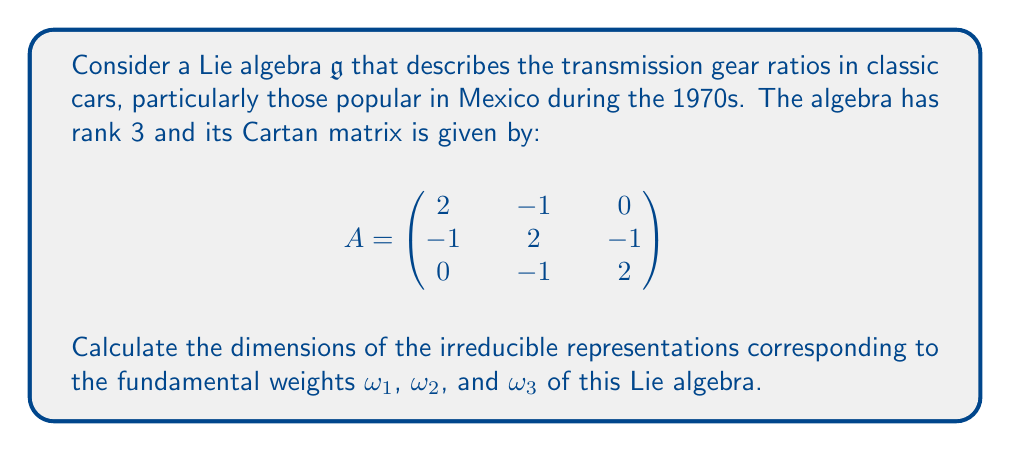Help me with this question. To find the dimensions of the irreducible representations, we'll use the Weyl dimension formula. For a representation with highest weight $\lambda$, the dimension is given by:

$$\dim V(\lambda) = \prod_{\alpha \in \Phi^+} \frac{(\lambda + \rho, \alpha)}{(\rho, \alpha)}$$

where $\Phi^+$ is the set of positive roots, and $\rho$ is half the sum of the positive roots.

1) First, we need to identify the Lie algebra. The Cartan matrix corresponds to the $A_3$ Lie algebra, which is isomorphic to $\mathfrak{sl}(4, \mathbb{C})$.

2) The positive roots for $A_3$ are:
   $\alpha_1, \alpha_2, \alpha_3, \alpha_1 + \alpha_2, \alpha_2 + \alpha_3, \alpha_1 + \alpha_2 + \alpha_3$

3) $\rho = \omega_1 + \omega_2 + \omega_3 = \frac{3}{2}\alpha_1 + 2\alpha_2 + \frac{3}{2}\alpha_3$

4) For $\omega_1$:
   $(\omega_1 + \rho, \alpha_1) = 2, (\omega_1 + \rho, \alpha_2) = 1, (\omega_1 + \rho, \alpha_3) = 1$
   $(\omega_1 + \rho, \alpha_1 + \alpha_2) = 3, (\omega_1 + \rho, \alpha_2 + \alpha_3) = 2, (\omega_1 + \rho, \alpha_1 + \alpha_2 + \alpha_3) = 4$

   $\dim V(\omega_1) = \frac{2}{1} \cdot \frac{1}{1} \cdot \frac{1}{1} \cdot \frac{3}{2} \cdot \frac{2}{2} \cdot \frac{4}{3} = 4$

5) For $\omega_2$:
   $(\omega_2 + \rho, \alpha_1) = 1, (\omega_2 + \rho, \alpha_2) = 2, (\omega_2 + \rho, \alpha_3) = 1$
   $(\omega_2 + \rho, \alpha_1 + \alpha_2) = 3, (\omega_2 + \rho, \alpha_2 + \alpha_3) = 3, (\omega_2 + \rho, \alpha_1 + \alpha_2 + \alpha_3) = 4$

   $\dim V(\omega_2) = \frac{1}{1} \cdot \frac{2}{1} \cdot \frac{1}{1} \cdot \frac{3}{2} \cdot \frac{3}{2} \cdot \frac{4}{3} = 6$

6) For $\omega_3$:
   $(\omega_3 + \rho, \alpha_1) = 1, (\omega_3 + \rho, \alpha_2) = 1, (\omega_3 + \rho, \alpha_3) = 2$
   $(\omega_3 + \rho, \alpha_1 + \alpha_2) = 2, (\omega_3 + \rho, \alpha_2 + \alpha_3) = 3, (\omega_3 + \rho, \alpha_1 + \alpha_2 + \alpha_3) = 4$

   $\dim V(\omega_3) = \frac{1}{1} \cdot \frac{1}{1} \cdot \frac{2}{1} \cdot \frac{2}{2} \cdot \frac{3}{2} \cdot \frac{4}{3} = 4$
Answer: The dimensions of the irreducible representations corresponding to the fundamental weights are:
$\dim V(\omega_1) = 4$
$\dim V(\omega_2) = 6$
$\dim V(\omega_3) = 4$ 